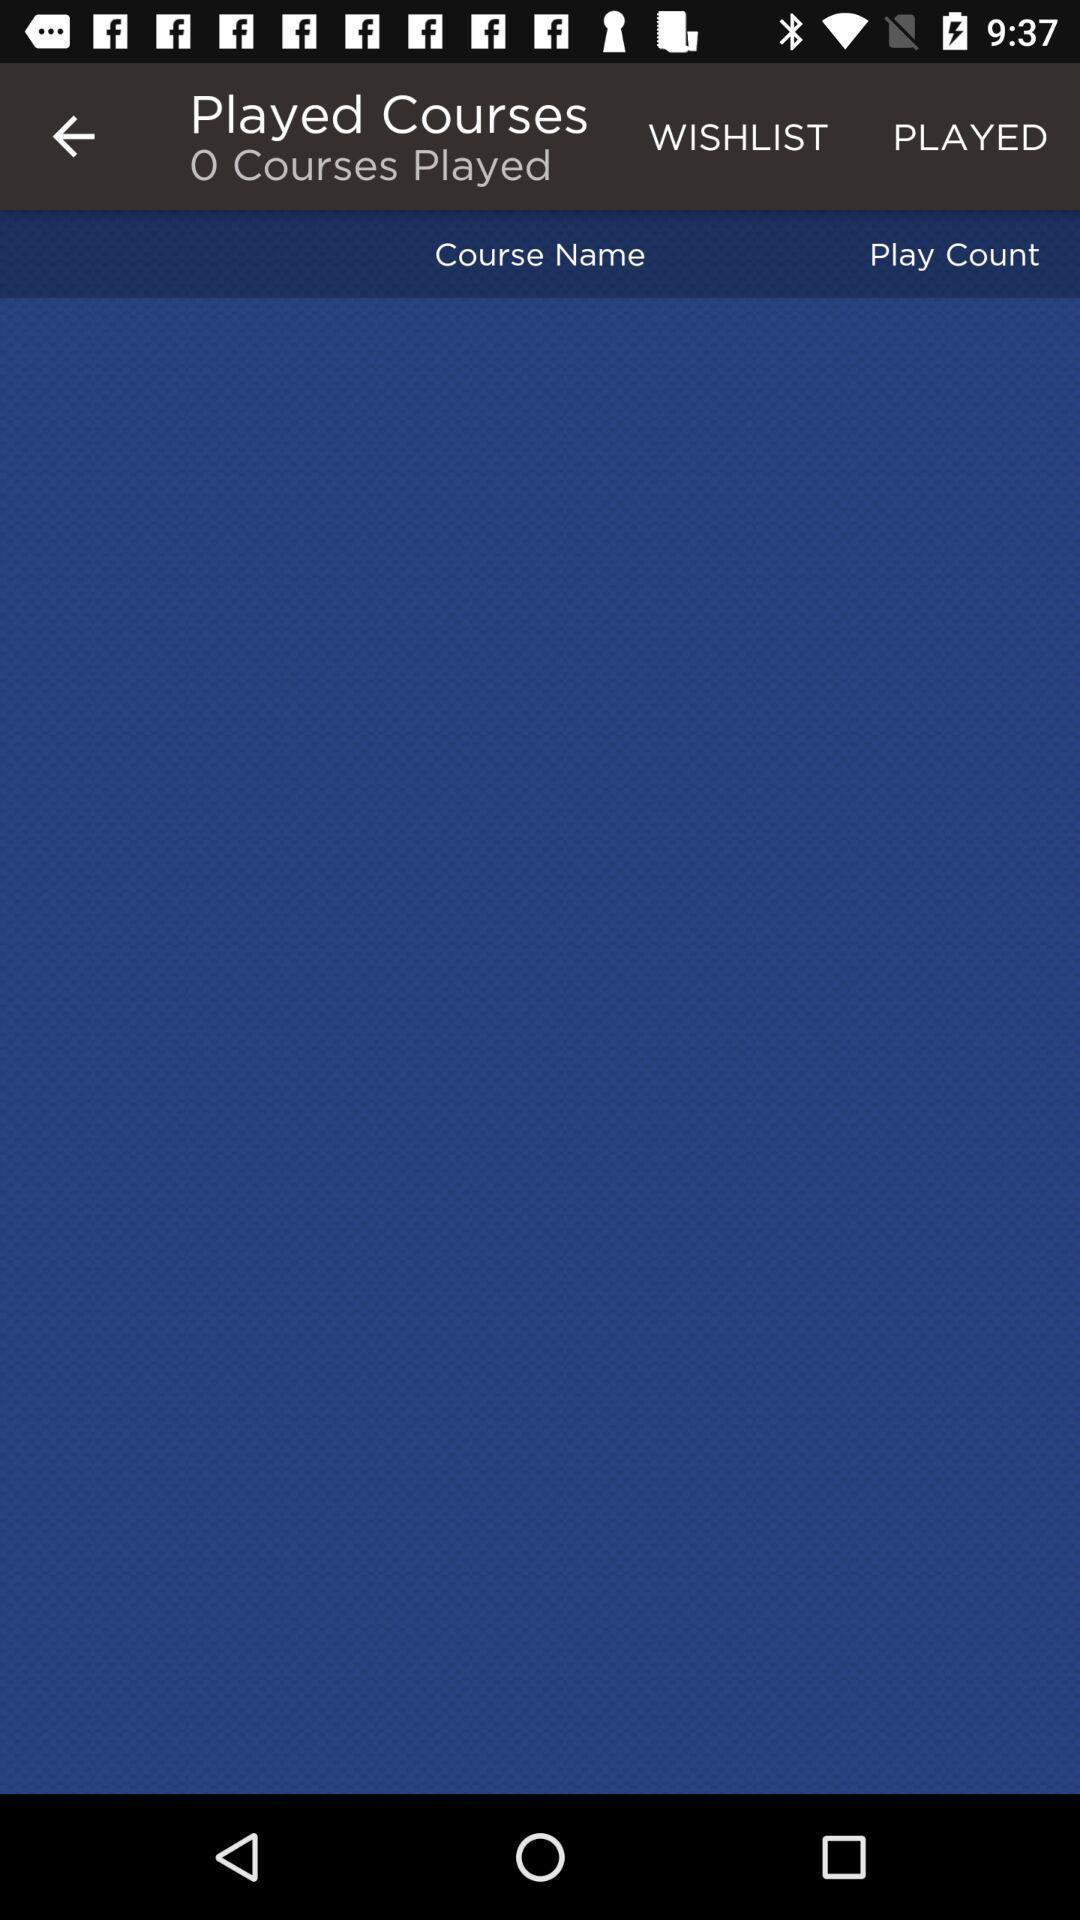What can you discern from this picture? Page displaying the blank under the courses option. 